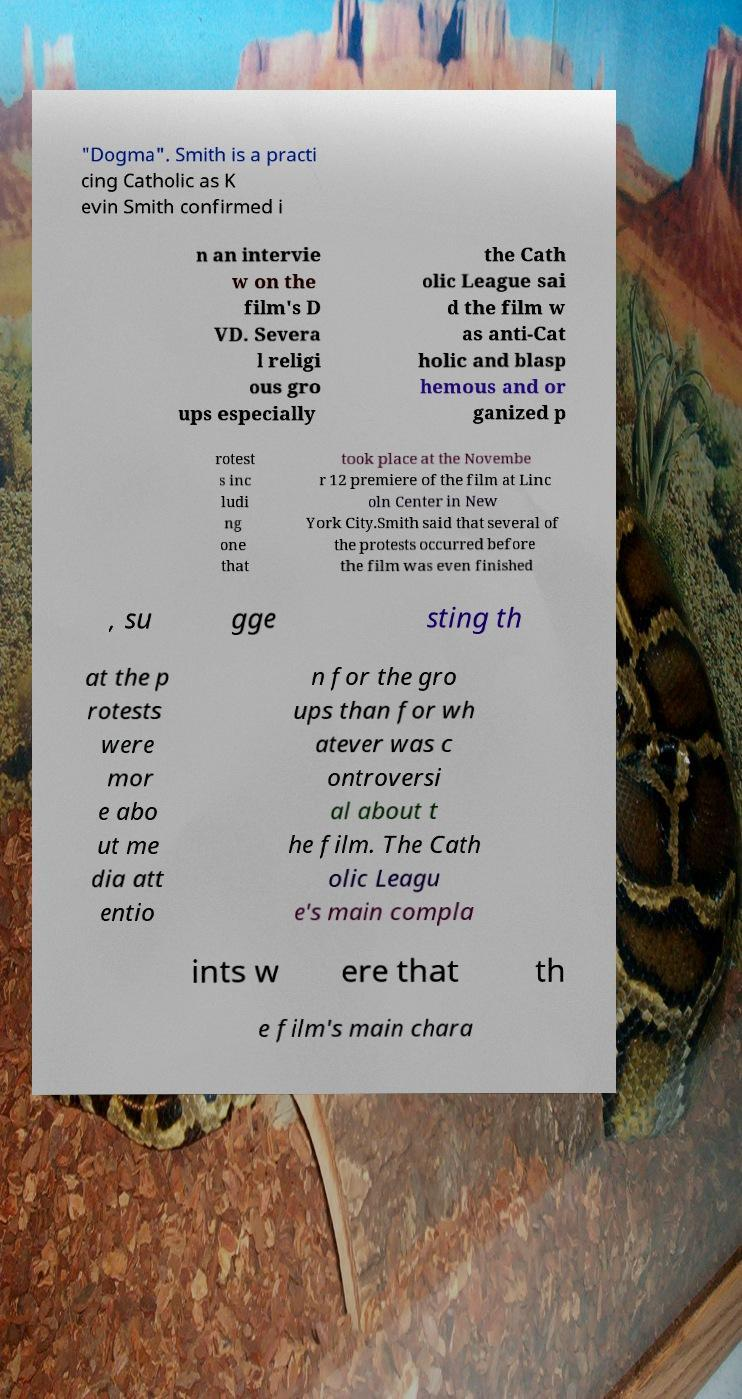Could you assist in decoding the text presented in this image and type it out clearly? "Dogma". Smith is a practi cing Catholic as K evin Smith confirmed i n an intervie w on the film's D VD. Severa l religi ous gro ups especially the Cath olic League sai d the film w as anti-Cat holic and blasp hemous and or ganized p rotest s inc ludi ng one that took place at the Novembe r 12 premiere of the film at Linc oln Center in New York City.Smith said that several of the protests occurred before the film was even finished , su gge sting th at the p rotests were mor e abo ut me dia att entio n for the gro ups than for wh atever was c ontroversi al about t he film. The Cath olic Leagu e's main compla ints w ere that th e film's main chara 